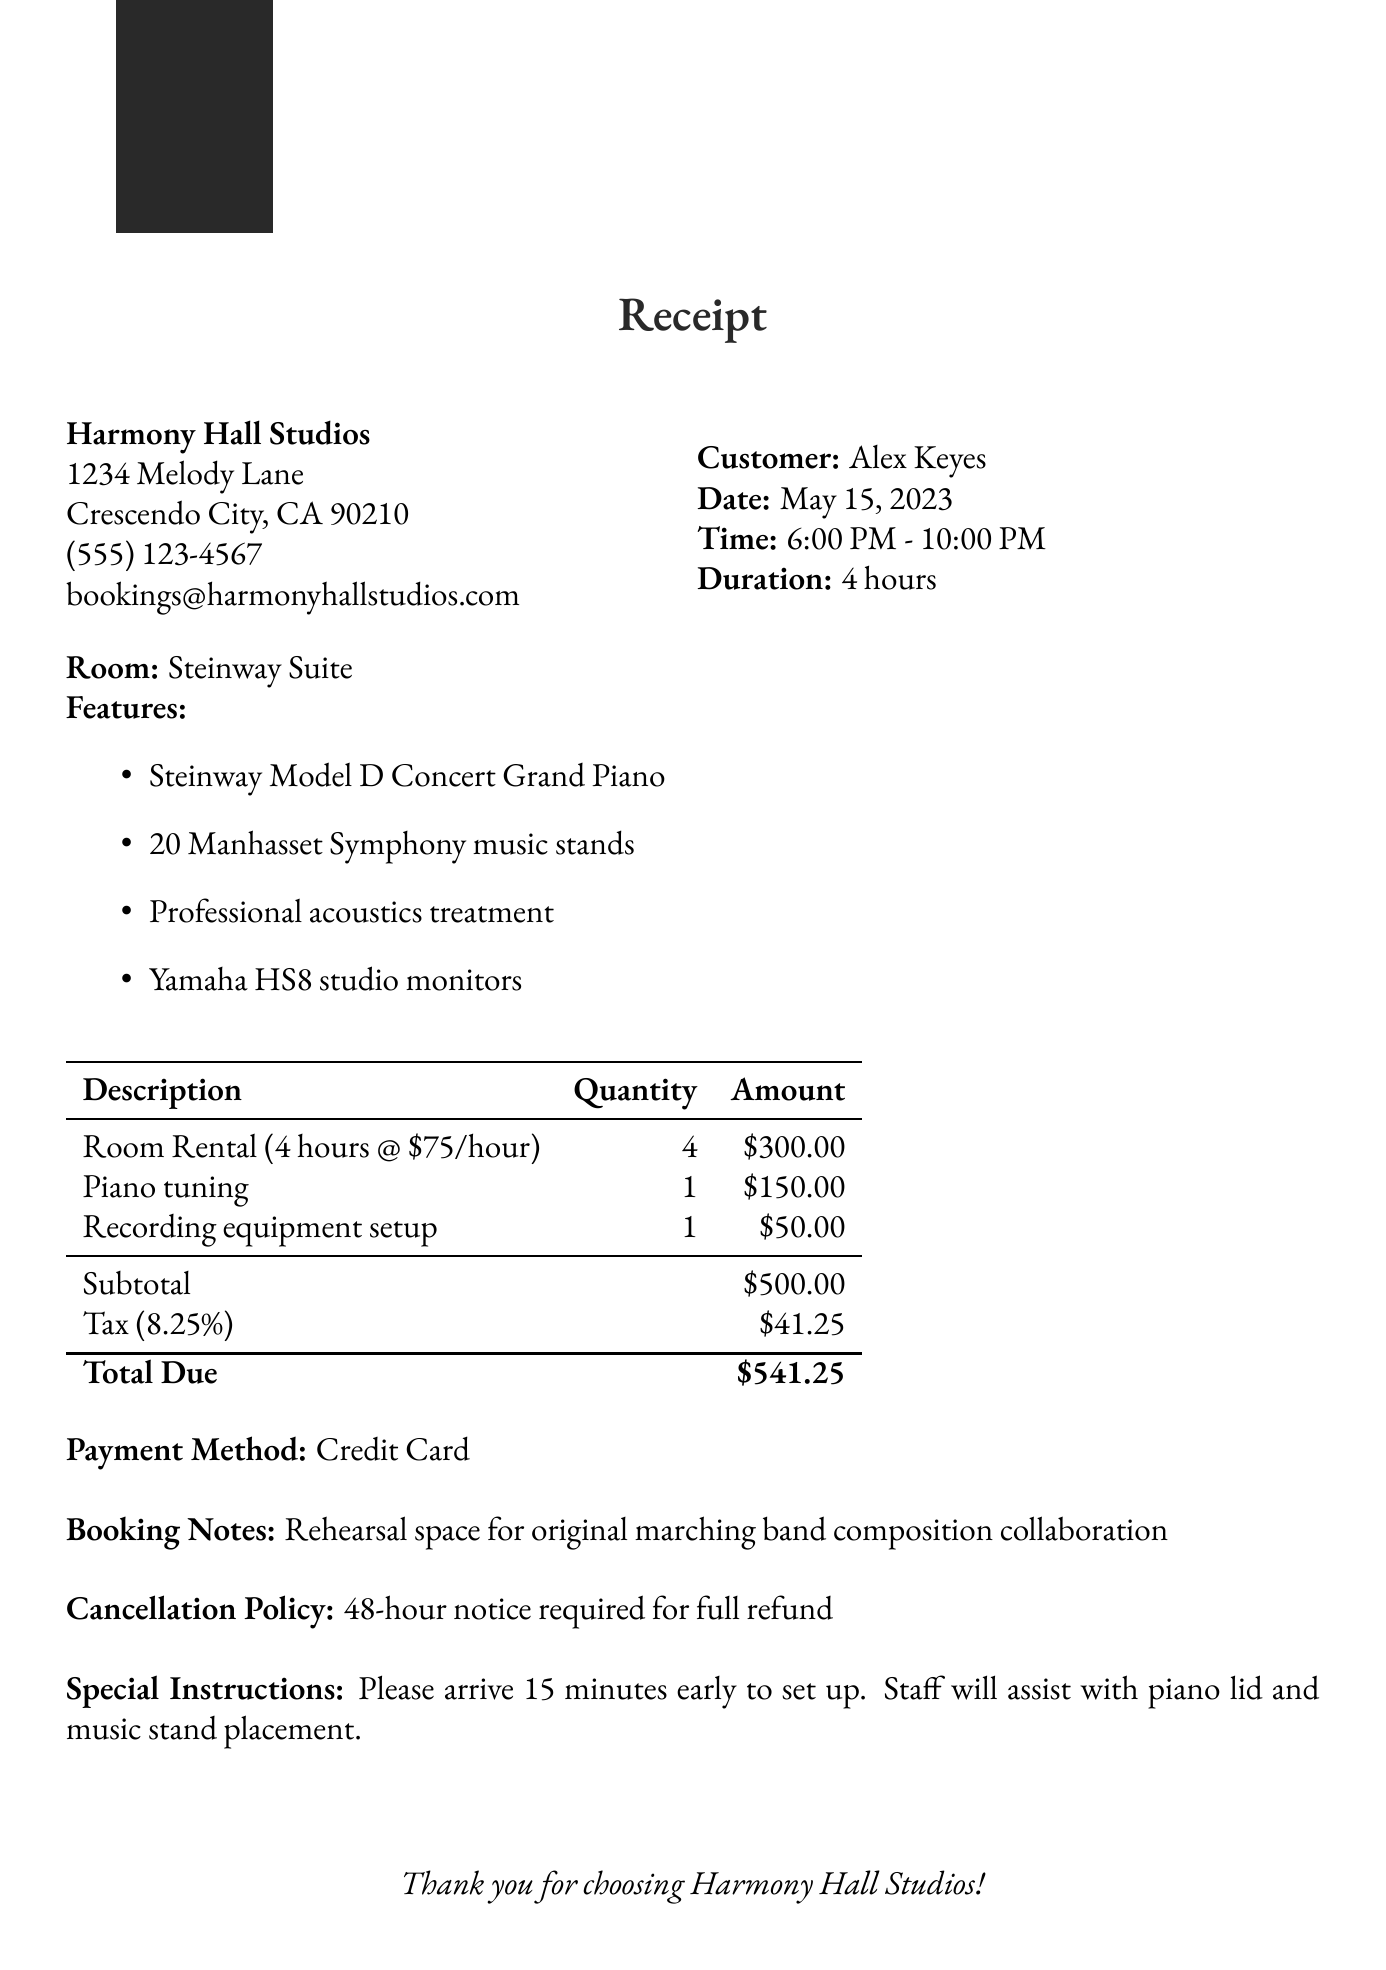What is the business name? The business name is stated at the top of the document, which is Harmony Hall Studios.
Answer: Harmony Hall Studios What is the rental duration? The rental duration is specified in the document, noted as the total time the space was booked for.
Answer: 4 hours What date was the rental? The rental date can be found in the document under the customer's information.
Answer: May 15, 2023 How much does piano tuning cost? The cost for piano tuning is itemized in the services provided in the document.
Answer: $150.00 What is the tax rate applied? The tax rate is mentioned in the financial section of the receipt.
Answer: 8.25% What is the total due amount? The total due amount is provided at the bottom of the invoice after calculating subtotal and tax.
Answer: $541.25 What payment method was used? The payment method is listed in the financial section of the receipt.
Answer: Credit Card What are the special instructions? The special instructions are provided towards the end of the document, specifying details for the customer's arrival.
Answer: Please arrive 15 minutes early to set up. Staff will assist with piano lid and music stand placement How many music stands are available? The number of music stands is listed under the room features section in the document.
Answer: 20 Manhasset Symphony music stands 